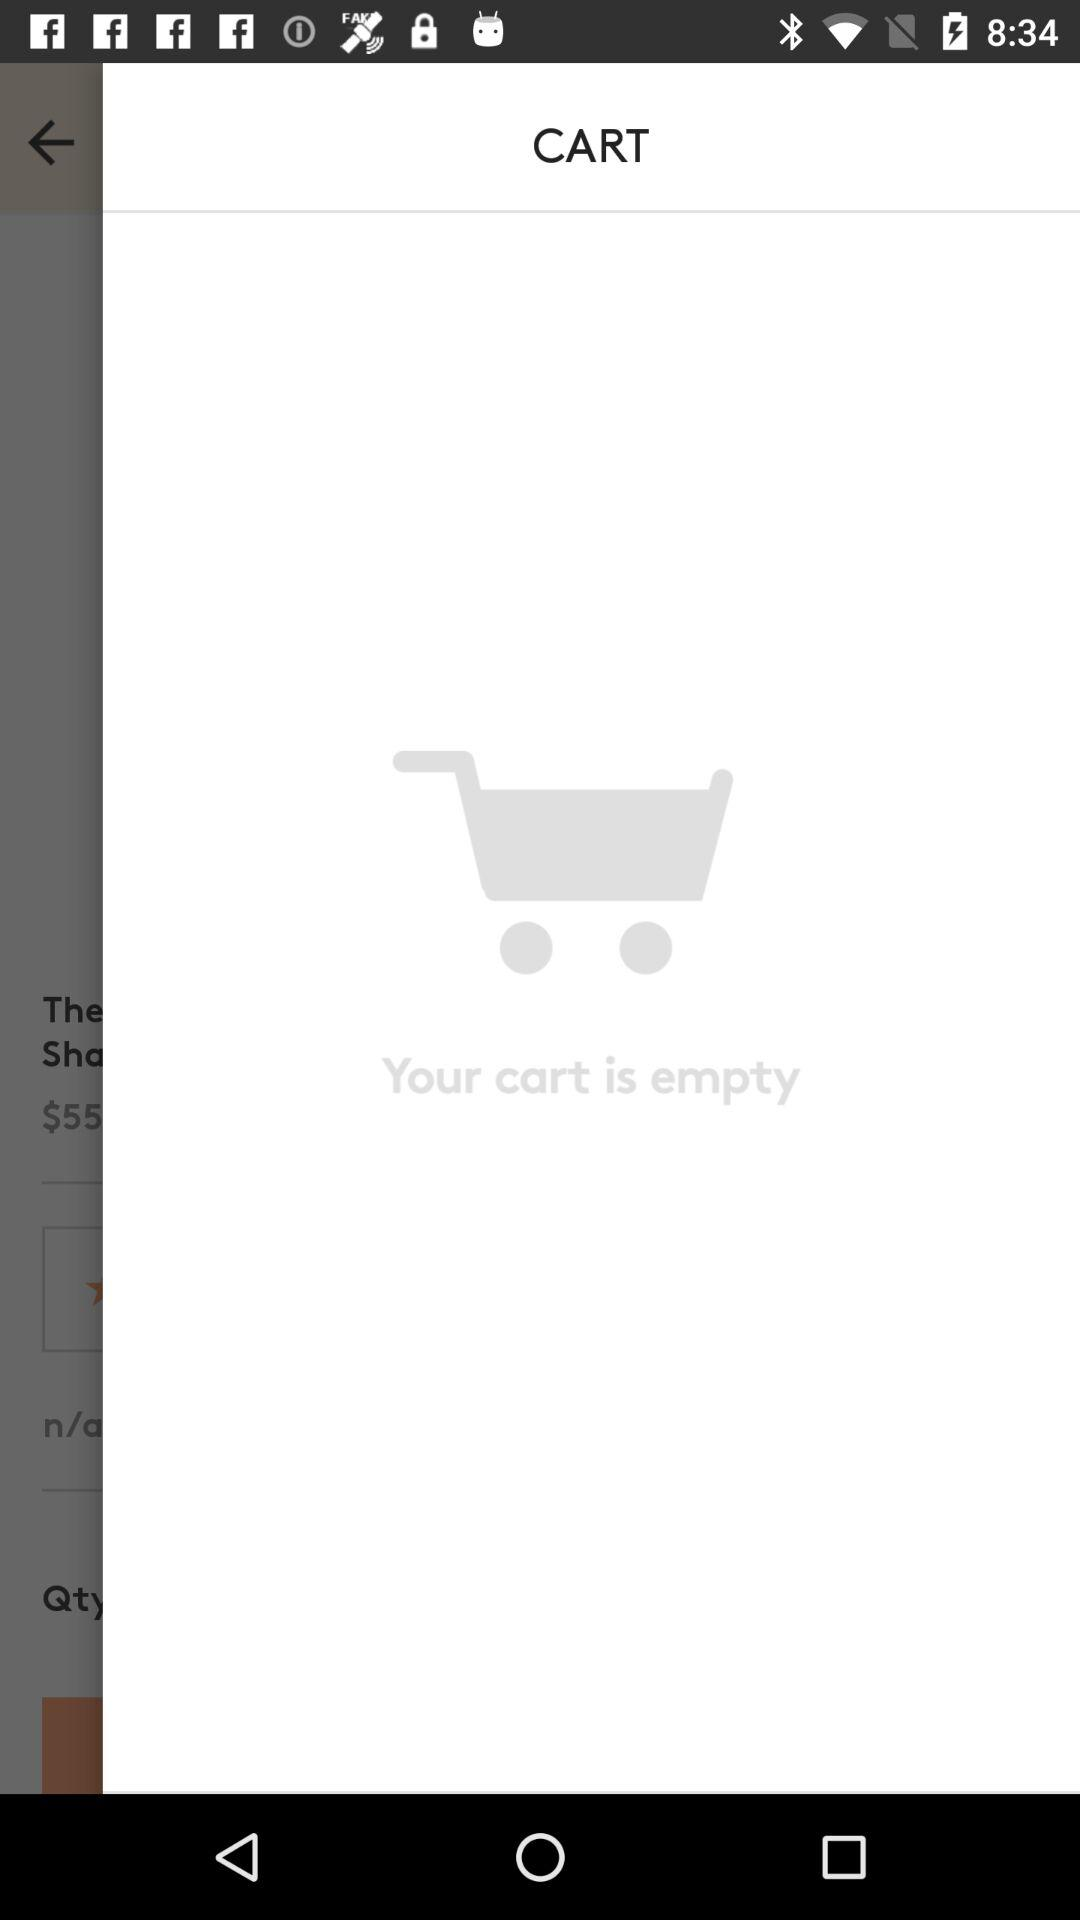Is there anything in the cart? The cart is empty. 